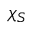<formula> <loc_0><loc_0><loc_500><loc_500>\chi _ { S }</formula> 